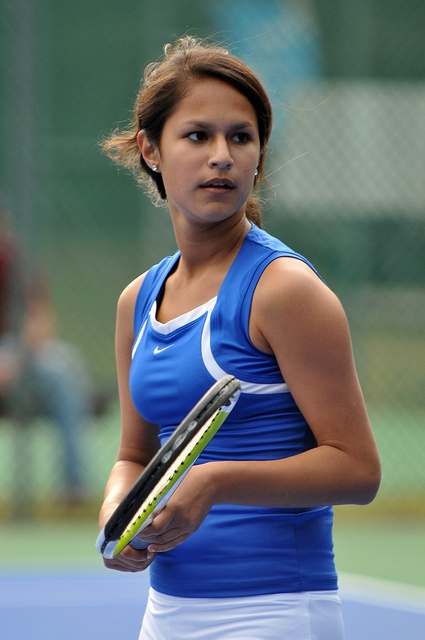Describe the objects in this image and their specific colors. I can see people in teal, gray, darkblue, black, and navy tones and tennis racket in teal, black, gray, darkgray, and ivory tones in this image. 